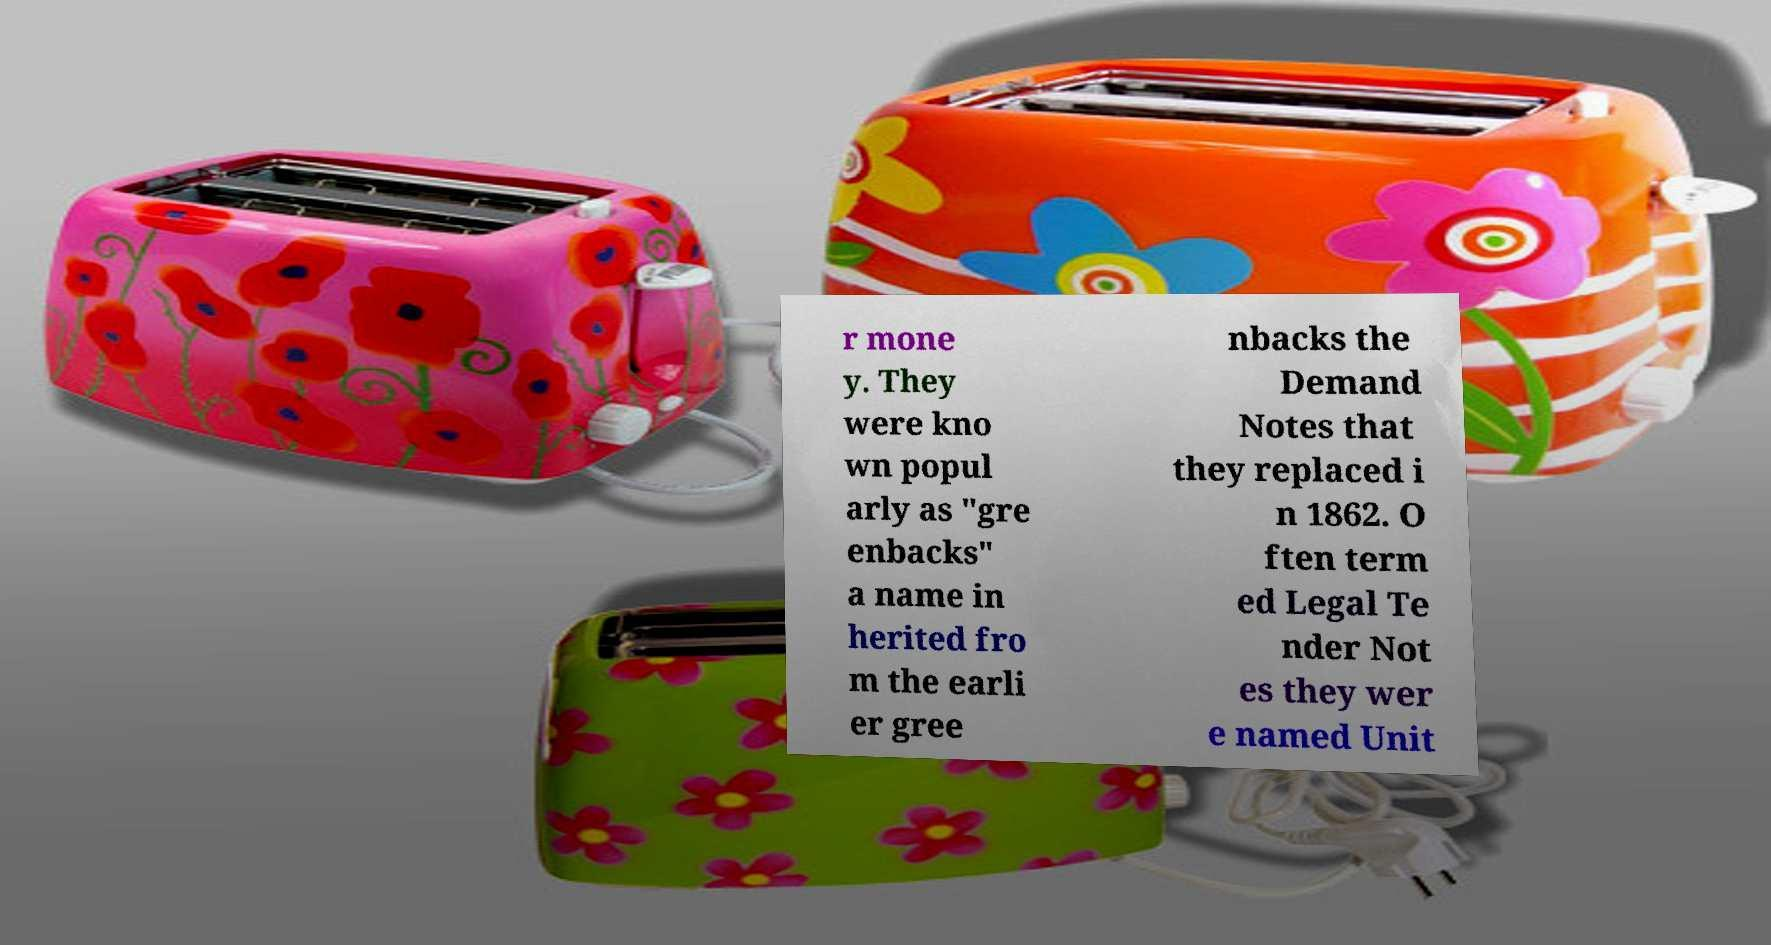For documentation purposes, I need the text within this image transcribed. Could you provide that? r mone y. They were kno wn popul arly as "gre enbacks" a name in herited fro m the earli er gree nbacks the Demand Notes that they replaced i n 1862. O ften term ed Legal Te nder Not es they wer e named Unit 